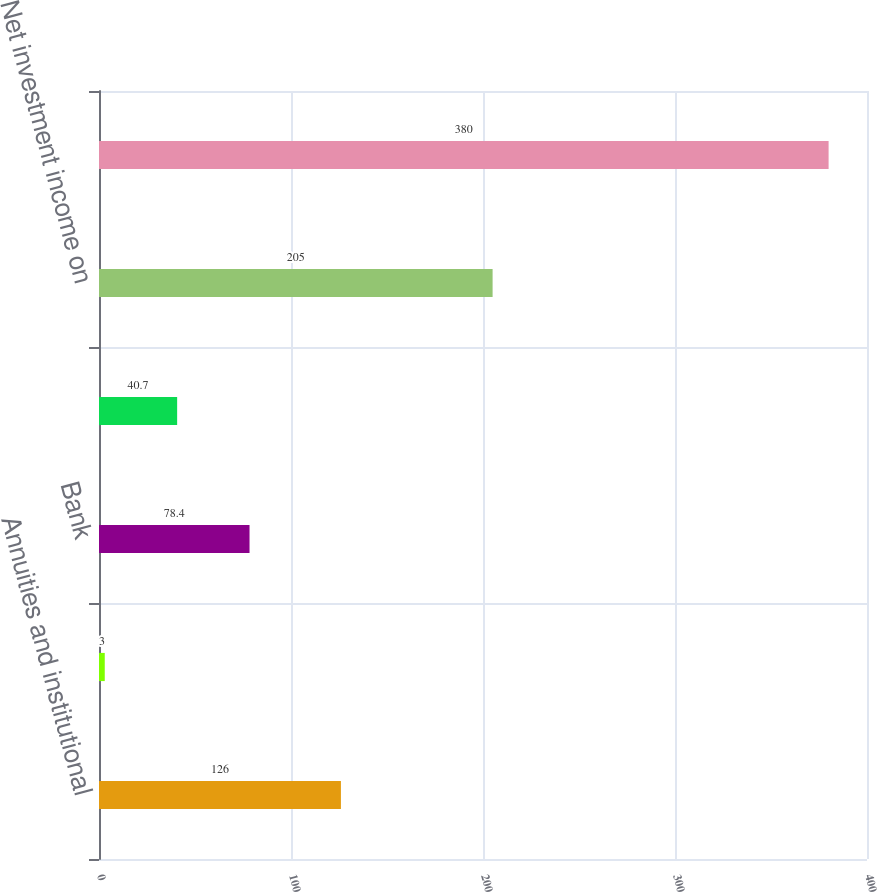<chart> <loc_0><loc_0><loc_500><loc_500><bar_chart><fcel>Annuities and institutional<fcel>Life insurance<fcel>Bank<fcel>Accident and health<fcel>Net investment income on<fcel>Total investment spread<nl><fcel>126<fcel>3<fcel>78.4<fcel>40.7<fcel>205<fcel>380<nl></chart> 